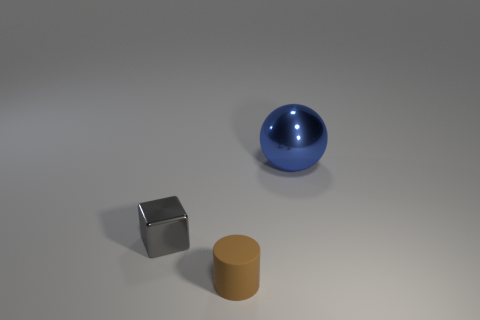Is there a blue sphere behind the metallic thing that is left of the large metal ball that is behind the gray cube?
Provide a short and direct response. Yes. There is a tiny thing that is in front of the tiny cube; does it have the same shape as the large thing?
Give a very brief answer. No. Is the number of matte cylinders on the right side of the tiny rubber thing less than the number of metallic things in front of the big blue thing?
Keep it short and to the point. Yes. What material is the big thing?
Give a very brief answer. Metal. There is a metal cube; what number of shiny objects are on the right side of it?
Your response must be concise. 1. Is the number of gray cubes on the right side of the gray shiny thing less than the number of matte cylinders?
Give a very brief answer. Yes. What is the color of the large metallic sphere?
Your response must be concise. Blue. How many large things are either yellow metal balls or blue spheres?
Provide a succinct answer. 1. What size is the thing to the left of the tiny brown object?
Your response must be concise. Small. What number of blue metal things are right of the metallic object that is left of the blue shiny thing?
Keep it short and to the point. 1. 